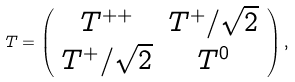Convert formula to latex. <formula><loc_0><loc_0><loc_500><loc_500>T = \left ( \begin{array} { c c c } { { T ^ { + + } } } & { { T ^ { + } / \sqrt { 2 } } } \\ { { T ^ { + } / \sqrt { 2 } } } & { { T ^ { 0 } } } \end{array} \right ) ,</formula> 